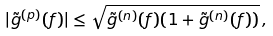<formula> <loc_0><loc_0><loc_500><loc_500>| \tilde { g } ^ { ( p ) } ( f ) | \leq \sqrt { \tilde { g } ^ { ( n ) } ( f ) ( 1 + \tilde { g } ^ { ( n ) } ( f ) ) } \, ,</formula> 